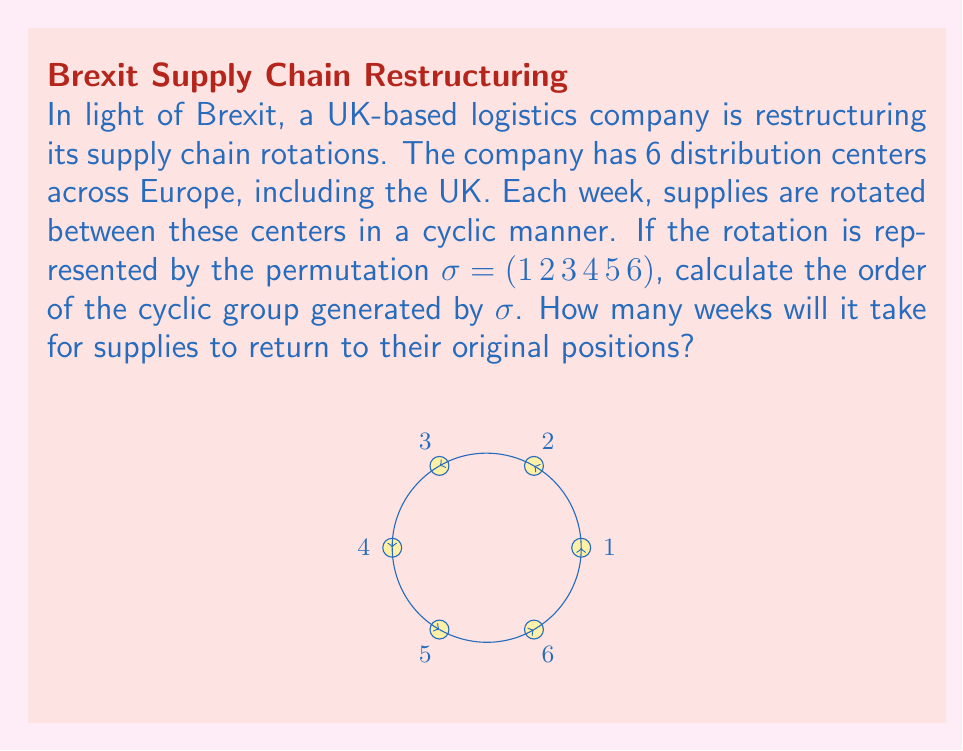Help me with this question. To solve this problem, we need to understand the concept of cyclic groups and permutation order:

1) The permutation $\sigma = (1\, 2\, 3\, 4\, 5\, 6)$ represents a cycle where each element moves to the next position, and the last element moves to the first position.

2) The order of a permutation is the smallest positive integer $n$ such that $\sigma^n = e$ (the identity permutation).

3) For a cycle, the order is equal to the length of the cycle.

4) In this case, the cycle has length 6, as it involves all 6 distribution centers.

5) Therefore, the order of the cyclic group generated by $\sigma$ is 6.

6) This means that after applying the permutation 6 times, we return to the original configuration:

   $\sigma^6 = (1\, 2\, 3\, 4\, 5\, 6)^6 = e$

7) In the context of the supply chain rotation, this implies that it will take 6 weeks for the supplies to return to their original positions.
Answer: 6 